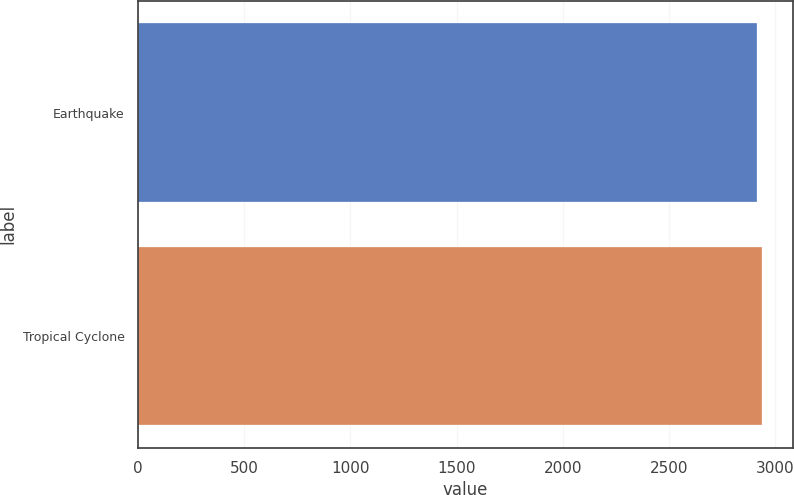Convert chart to OTSL. <chart><loc_0><loc_0><loc_500><loc_500><bar_chart><fcel>Earthquake<fcel>Tropical Cyclone<nl><fcel>2912<fcel>2937<nl></chart> 